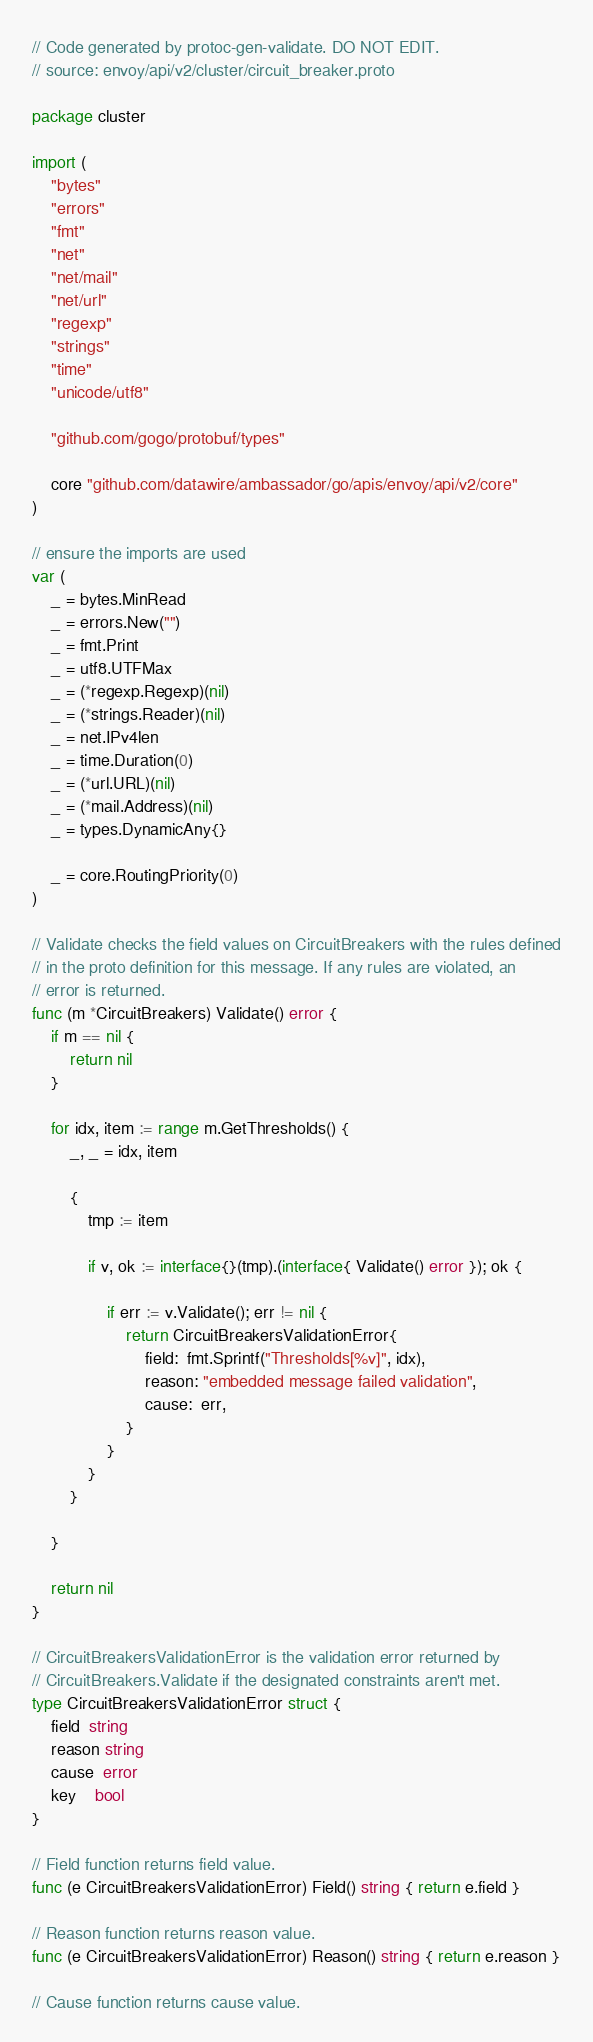<code> <loc_0><loc_0><loc_500><loc_500><_Go_>// Code generated by protoc-gen-validate. DO NOT EDIT.
// source: envoy/api/v2/cluster/circuit_breaker.proto

package cluster

import (
	"bytes"
	"errors"
	"fmt"
	"net"
	"net/mail"
	"net/url"
	"regexp"
	"strings"
	"time"
	"unicode/utf8"

	"github.com/gogo/protobuf/types"

	core "github.com/datawire/ambassador/go/apis/envoy/api/v2/core"
)

// ensure the imports are used
var (
	_ = bytes.MinRead
	_ = errors.New("")
	_ = fmt.Print
	_ = utf8.UTFMax
	_ = (*regexp.Regexp)(nil)
	_ = (*strings.Reader)(nil)
	_ = net.IPv4len
	_ = time.Duration(0)
	_ = (*url.URL)(nil)
	_ = (*mail.Address)(nil)
	_ = types.DynamicAny{}

	_ = core.RoutingPriority(0)
)

// Validate checks the field values on CircuitBreakers with the rules defined
// in the proto definition for this message. If any rules are violated, an
// error is returned.
func (m *CircuitBreakers) Validate() error {
	if m == nil {
		return nil
	}

	for idx, item := range m.GetThresholds() {
		_, _ = idx, item

		{
			tmp := item

			if v, ok := interface{}(tmp).(interface{ Validate() error }); ok {

				if err := v.Validate(); err != nil {
					return CircuitBreakersValidationError{
						field:  fmt.Sprintf("Thresholds[%v]", idx),
						reason: "embedded message failed validation",
						cause:  err,
					}
				}
			}
		}

	}

	return nil
}

// CircuitBreakersValidationError is the validation error returned by
// CircuitBreakers.Validate if the designated constraints aren't met.
type CircuitBreakersValidationError struct {
	field  string
	reason string
	cause  error
	key    bool
}

// Field function returns field value.
func (e CircuitBreakersValidationError) Field() string { return e.field }

// Reason function returns reason value.
func (e CircuitBreakersValidationError) Reason() string { return e.reason }

// Cause function returns cause value.</code> 